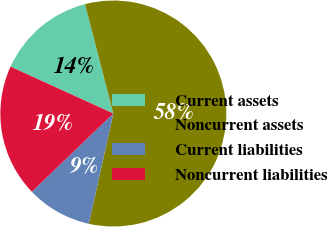Convert chart to OTSL. <chart><loc_0><loc_0><loc_500><loc_500><pie_chart><fcel>Current assets<fcel>Noncurrent assets<fcel>Current liabilities<fcel>Noncurrent liabilities<nl><fcel>14.16%<fcel>57.53%<fcel>9.34%<fcel>18.98%<nl></chart> 